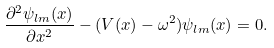Convert formula to latex. <formula><loc_0><loc_0><loc_500><loc_500>\frac { \partial ^ { 2 } \psi _ { l m } ( x ) } { \partial x ^ { 2 } } - ( V ( x ) - \omega ^ { 2 } ) \psi _ { l m } ( x ) = 0 .</formula> 